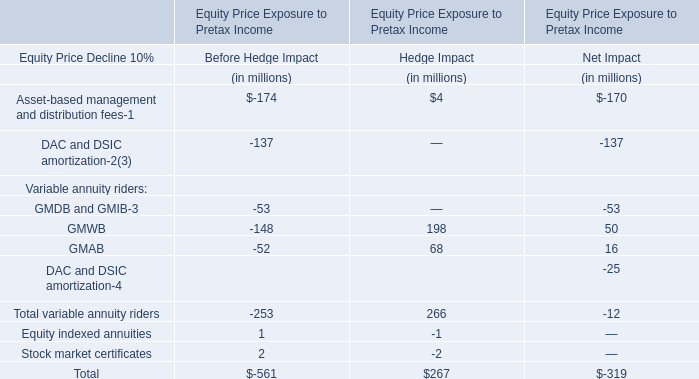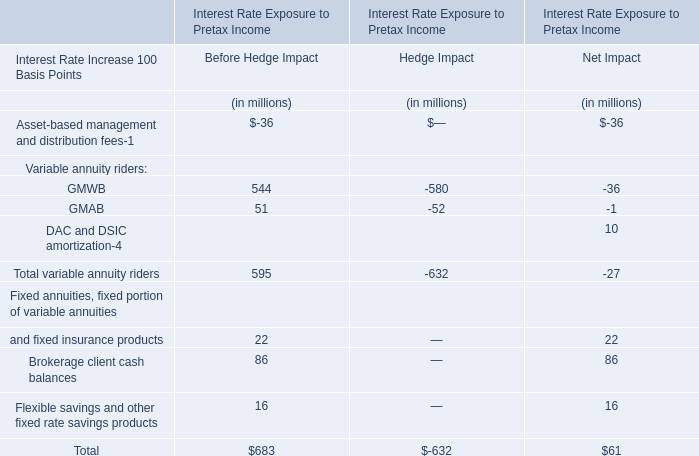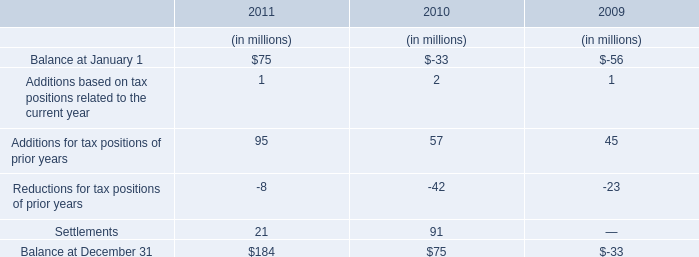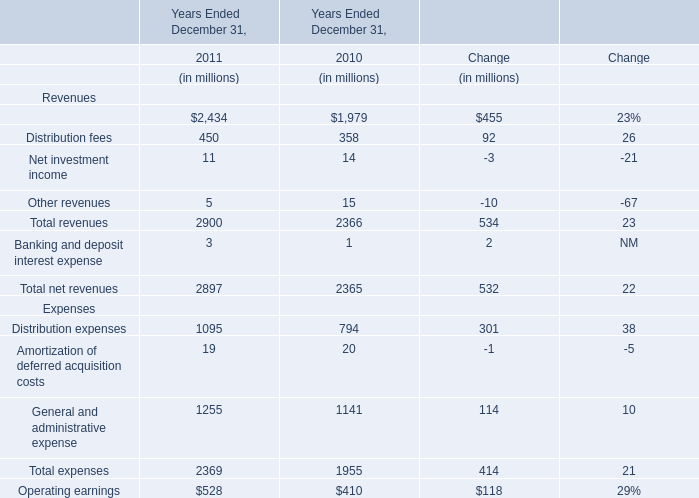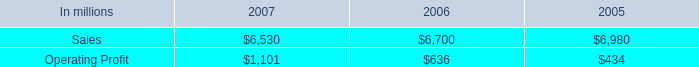Without Distribution fees and Management and financial advice fees, how much of revenues is there in total in 2011? (in millions) 
Computations: ((2900 - 2434) - 450)
Answer: 16.0. 